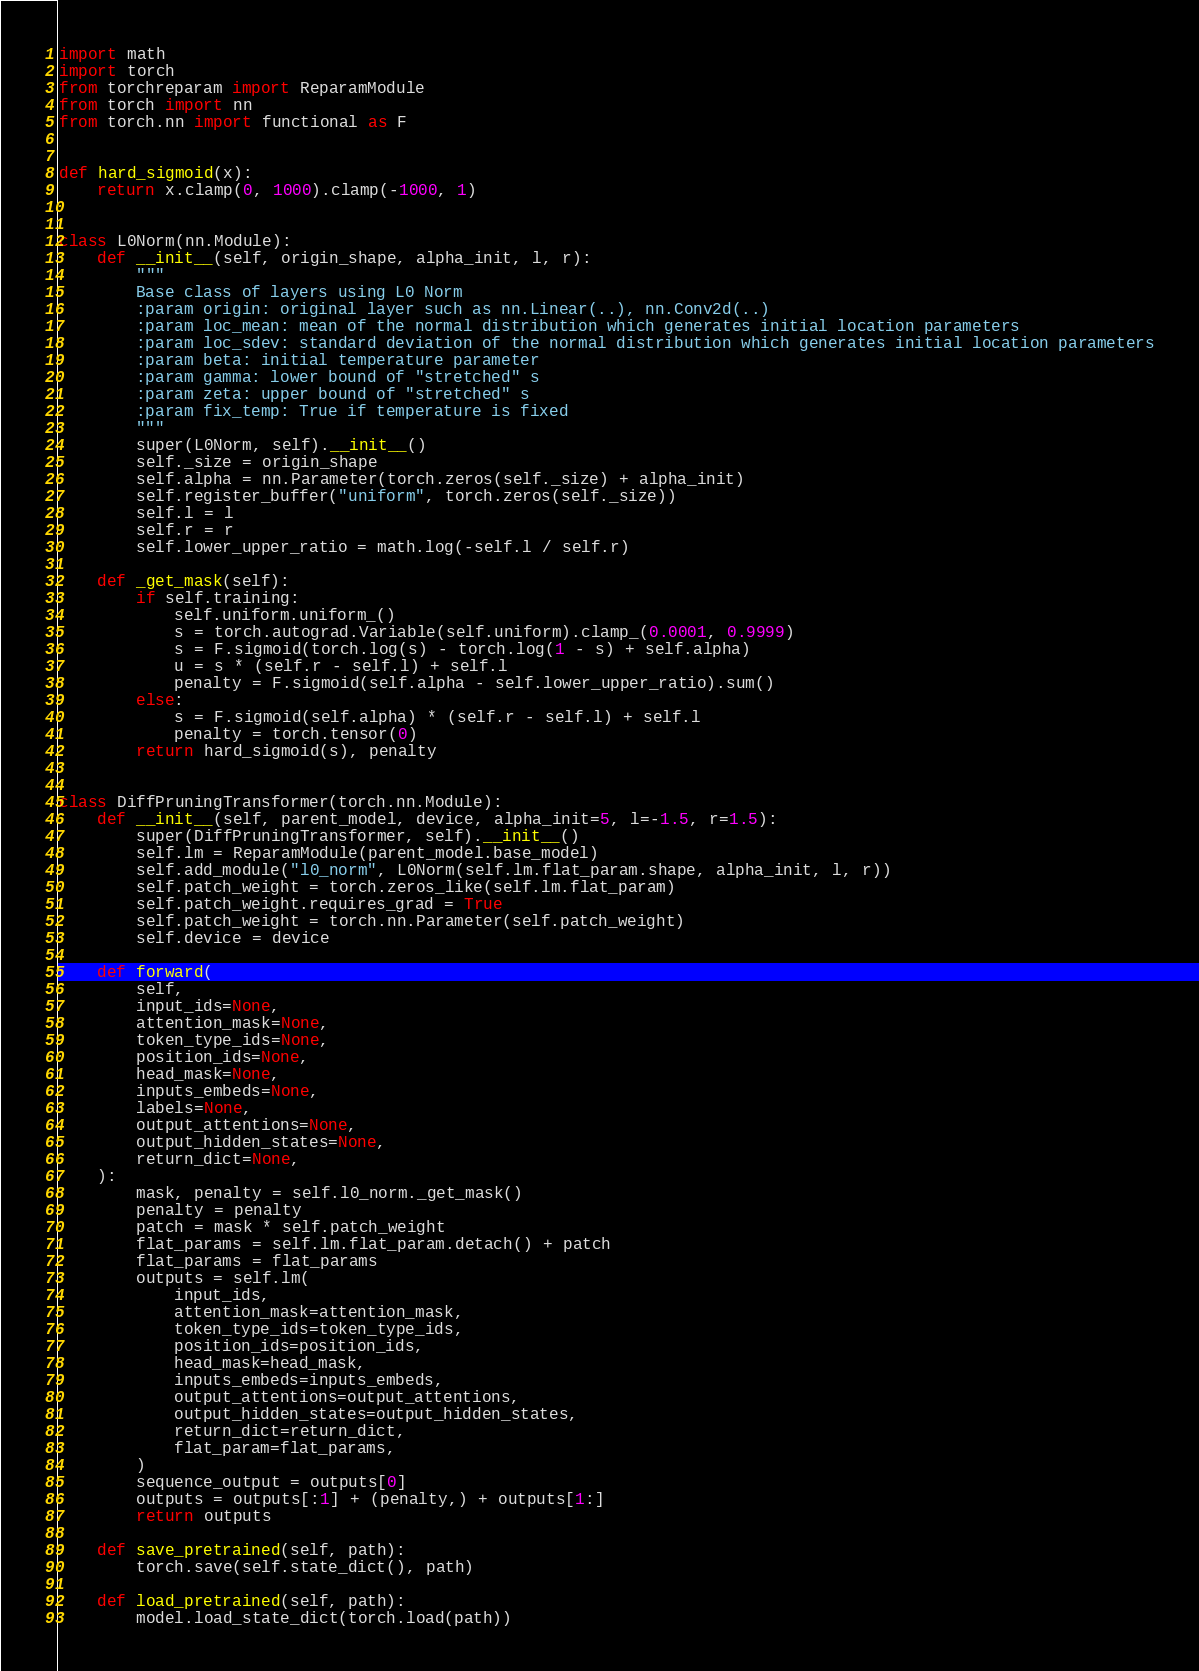<code> <loc_0><loc_0><loc_500><loc_500><_Python_>import math
import torch
from torchreparam import ReparamModule
from torch import nn
from torch.nn import functional as F


def hard_sigmoid(x):
    return x.clamp(0, 1000).clamp(-1000, 1)


class L0Norm(nn.Module):
    def __init__(self, origin_shape, alpha_init, l, r):
        """
        Base class of layers using L0 Norm
        :param origin: original layer such as nn.Linear(..), nn.Conv2d(..)
        :param loc_mean: mean of the normal distribution which generates initial location parameters
        :param loc_sdev: standard deviation of the normal distribution which generates initial location parameters
        :param beta: initial temperature parameter
        :param gamma: lower bound of "stretched" s
        :param zeta: upper bound of "stretched" s
        :param fix_temp: True if temperature is fixed
        """
        super(L0Norm, self).__init__()
        self._size = origin_shape
        self.alpha = nn.Parameter(torch.zeros(self._size) + alpha_init)
        self.register_buffer("uniform", torch.zeros(self._size))
        self.l = l
        self.r = r
        self.lower_upper_ratio = math.log(-self.l / self.r)

    def _get_mask(self):
        if self.training:
            self.uniform.uniform_()
            s = torch.autograd.Variable(self.uniform).clamp_(0.0001, 0.9999)
            s = F.sigmoid(torch.log(s) - torch.log(1 - s) + self.alpha)
            u = s * (self.r - self.l) + self.l
            penalty = F.sigmoid(self.alpha - self.lower_upper_ratio).sum()
        else:
            s = F.sigmoid(self.alpha) * (self.r - self.l) + self.l
            penalty = torch.tensor(0)
        return hard_sigmoid(s), penalty


class DiffPruningTransformer(torch.nn.Module):
    def __init__(self, parent_model, device, alpha_init=5, l=-1.5, r=1.5):
        super(DiffPruningTransformer, self).__init__()
        self.lm = ReparamModule(parent_model.base_model)
        self.add_module("l0_norm", L0Norm(self.lm.flat_param.shape, alpha_init, l, r))
        self.patch_weight = torch.zeros_like(self.lm.flat_param)
        self.patch_weight.requires_grad = True
        self.patch_weight = torch.nn.Parameter(self.patch_weight)
        self.device = device

    def forward(
        self,
        input_ids=None,
        attention_mask=None,
        token_type_ids=None,
        position_ids=None,
        head_mask=None,
        inputs_embeds=None,
        labels=None,
        output_attentions=None,
        output_hidden_states=None,
        return_dict=None,
    ):
        mask, penalty = self.l0_norm._get_mask()
        penalty = penalty
        patch = mask * self.patch_weight
        flat_params = self.lm.flat_param.detach() + patch
        flat_params = flat_params
        outputs = self.lm(
            input_ids,
            attention_mask=attention_mask,
            token_type_ids=token_type_ids,
            position_ids=position_ids,
            head_mask=head_mask,
            inputs_embeds=inputs_embeds,
            output_attentions=output_attentions,
            output_hidden_states=output_hidden_states,
            return_dict=return_dict,
            flat_param=flat_params,
        )
        sequence_output = outputs[0]
        outputs = outputs[:1] + (penalty,) + outputs[1:]
        return outputs

    def save_pretrained(self, path):
        torch.save(self.state_dict(), path)

    def load_pretrained(self, path):
        model.load_state_dict(torch.load(path))
</code> 